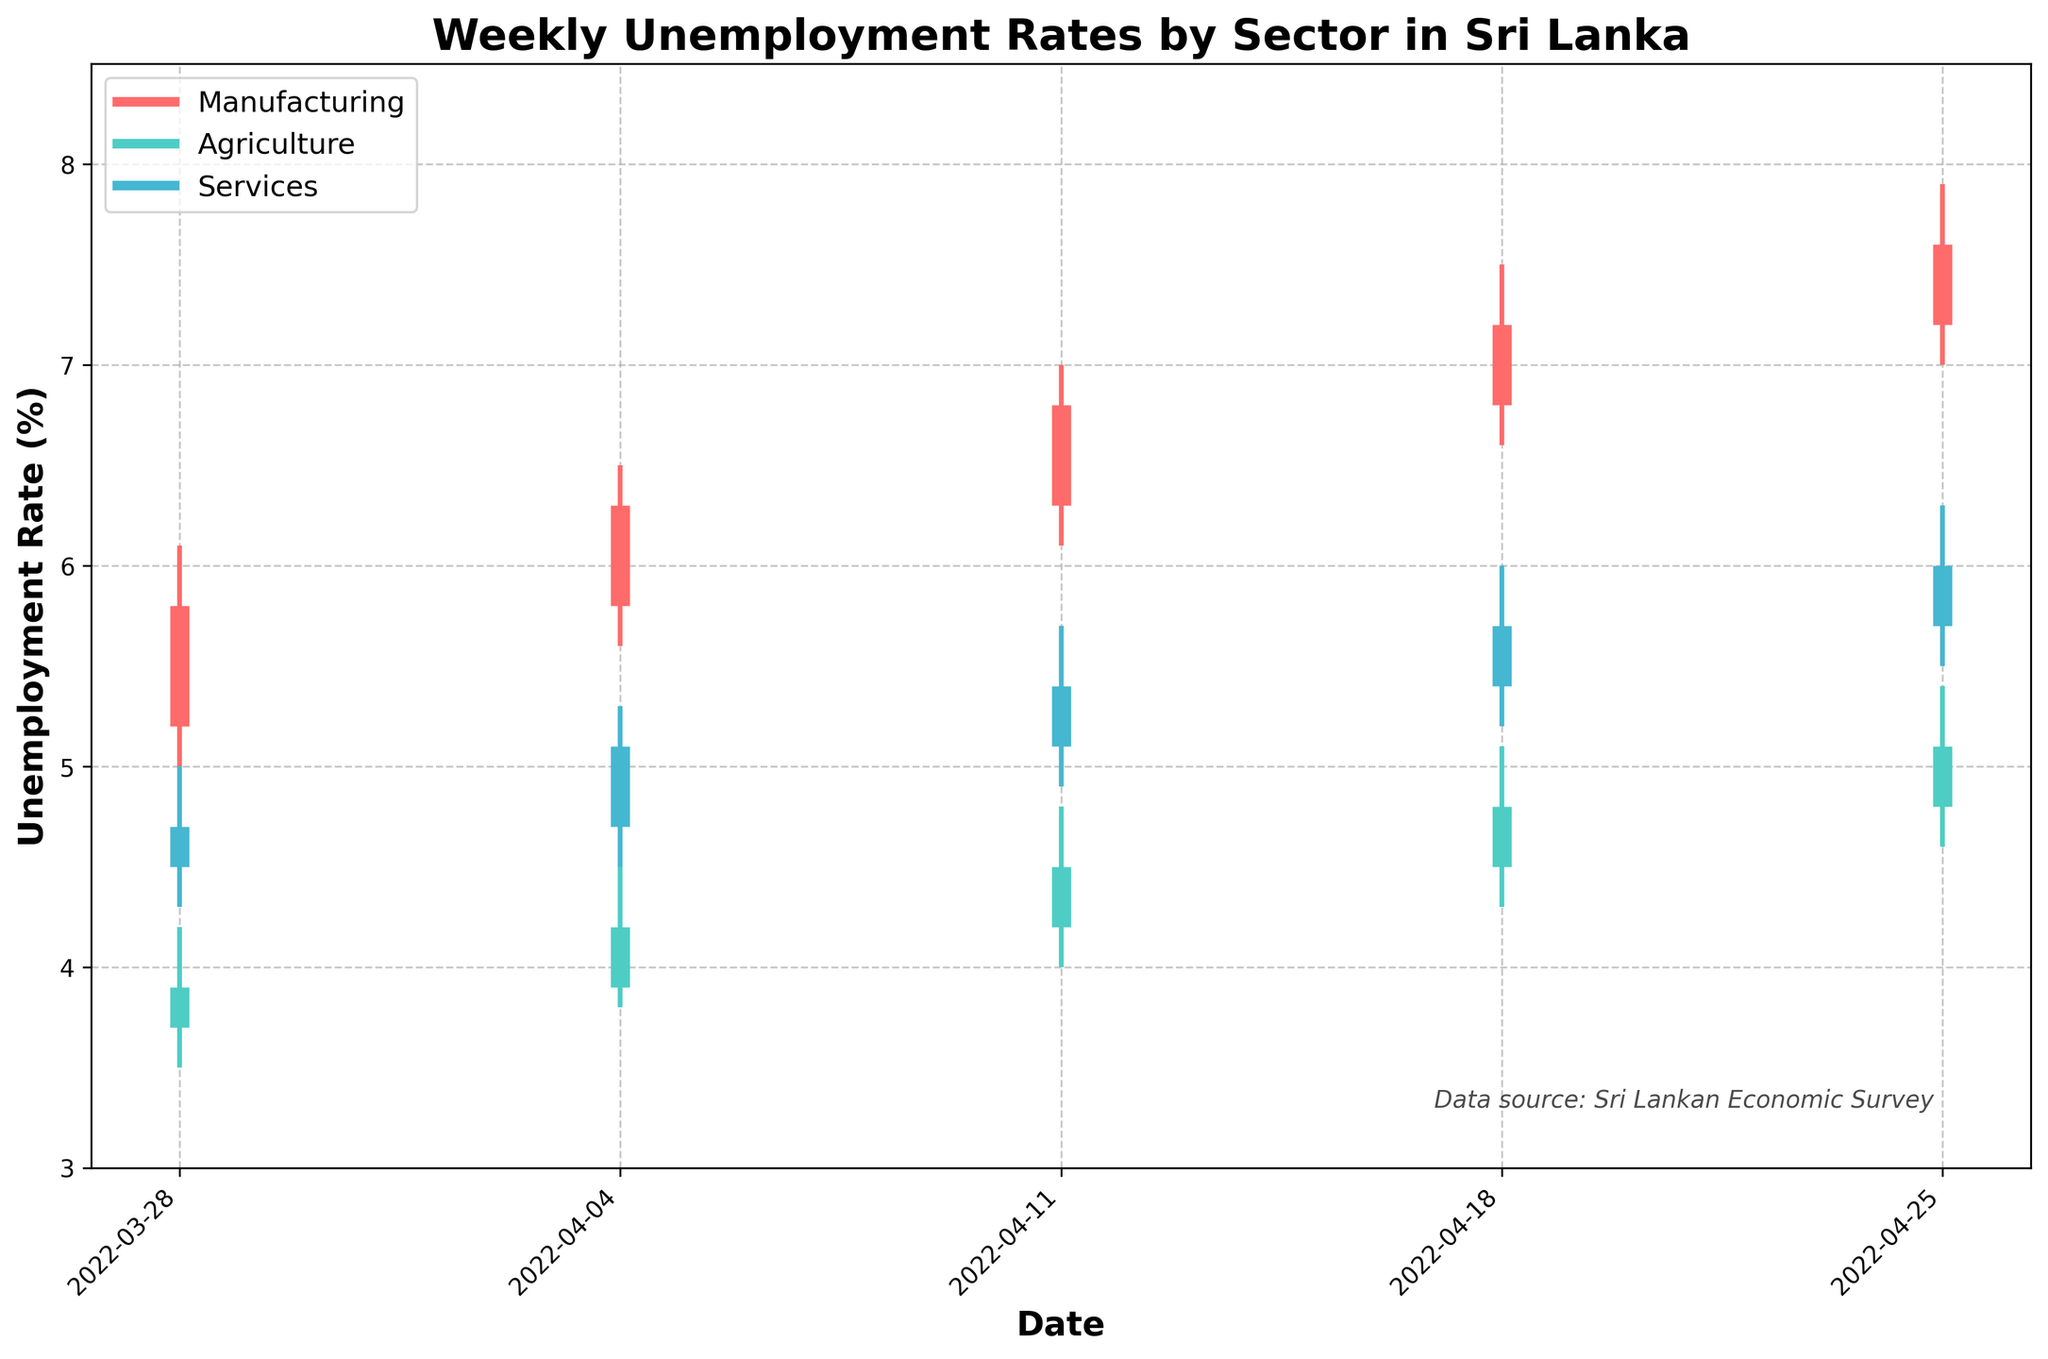What is the title of the chart? The title is at the top of the chart in bold font and reads "Weekly Unemployment Rates by Sector in Sri Lanka."
Answer: "Weekly Unemployment Rates by Sector in Sri Lanka." What sectors are represented in this chart? The legend in the chart shows three different sectors: Manufacturing, Agriculture, and Services, each represented by a different color.
Answer: Manufacturing, Agriculture, Services Which sector had the highest unemployment rate during the week of 2022-04-25? By observing the vertical lines for each sector on the date 2022-04-25, Manufacturing shows a higher rate with the highest point reaching 7.9%.
Answer: Manufacturing What was the lowest unemployment rate in the Agriculture sector during the given period? Referring to the lowest points of the lines in Agriculture (green color), the minimum value appears on 2022-03-28 at 3.5%.
Answer: 3.5% How did the unemployment rate in the Services sector change from 2022-03-28 to 2022-04-25? Observing the close values for Services on these dates, it increased from 4.7% to 6.0%, showing a gradual upward trend.
Answer: Increased from 4.7% to 6.0% What trend can be observed in the Manufacturing sector over the entire period? By analyzing the progress of the lines for Manufacturing from the start to the end date, it's clear that there is a consistent upward trend in unemployment rates.
Answer: An upward trend What was the highest unemployment rate observed in any sector during the given time period? Looking at the highest points on any of the lines, the Manufacturing sector reached the highest rate of 7.9% on 2022-04-25.
Answer: 7.9% Compare the unemployment rates in Agriculture and Services sectors for the week of 2022-04-18. Which one was higher and by how much? In the week of 2022-04-18, the close value for Agriculture was 4.8% and for Services was 5.7%. Services was higher by 0.9%.
Answer: Services by 0.9% By how much did the Manufacturing sector's unemployment rate increase from the week of 2022-03-28 to 2022-04-25? Calculate the difference between the close values of Manufacturing on these dates: 7.6% - 5.8% = 1.8%.
Answer: 1.8% What is the overall pattern observed for the Agriculture sector across these weeks? By examining the data points longitudinally, the Agriculture sector shows a general upward trend in unemployment rates, though it fluctuates less compared to Manufacturing.
Answer: Gradual upward trend with less fluctuation 